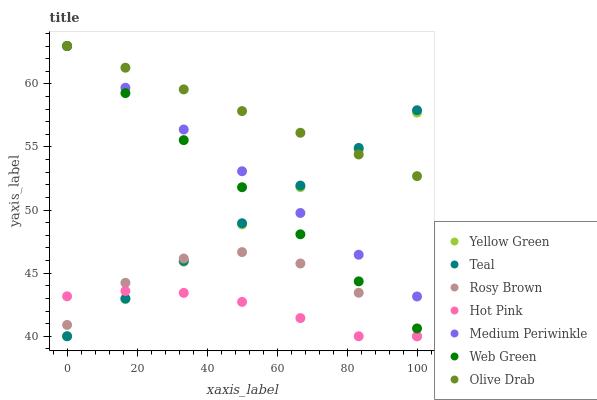Does Hot Pink have the minimum area under the curve?
Answer yes or no. Yes. Does Olive Drab have the maximum area under the curve?
Answer yes or no. Yes. Does Yellow Green have the minimum area under the curve?
Answer yes or no. No. Does Yellow Green have the maximum area under the curve?
Answer yes or no. No. Is Olive Drab the smoothest?
Answer yes or no. Yes. Is Rosy Brown the roughest?
Answer yes or no. Yes. Is Yellow Green the smoothest?
Answer yes or no. No. Is Yellow Green the roughest?
Answer yes or no. No. Does Hot Pink have the lowest value?
Answer yes or no. Yes. Does Medium Periwinkle have the lowest value?
Answer yes or no. No. Does Olive Drab have the highest value?
Answer yes or no. Yes. Does Yellow Green have the highest value?
Answer yes or no. No. Is Hot Pink less than Olive Drab?
Answer yes or no. Yes. Is Medium Periwinkle greater than Rosy Brown?
Answer yes or no. Yes. Does Teal intersect Hot Pink?
Answer yes or no. Yes. Is Teal less than Hot Pink?
Answer yes or no. No. Is Teal greater than Hot Pink?
Answer yes or no. No. Does Hot Pink intersect Olive Drab?
Answer yes or no. No. 